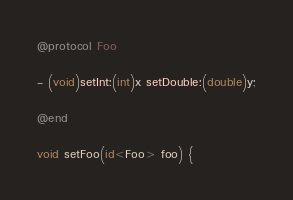Convert code to text. <code><loc_0><loc_0><loc_500><loc_500><_ObjectiveC_>@protocol Foo

- (void)setInt:(int)x setDouble:(double)y;

@end

void setFoo(id<Foo> foo) {</code> 